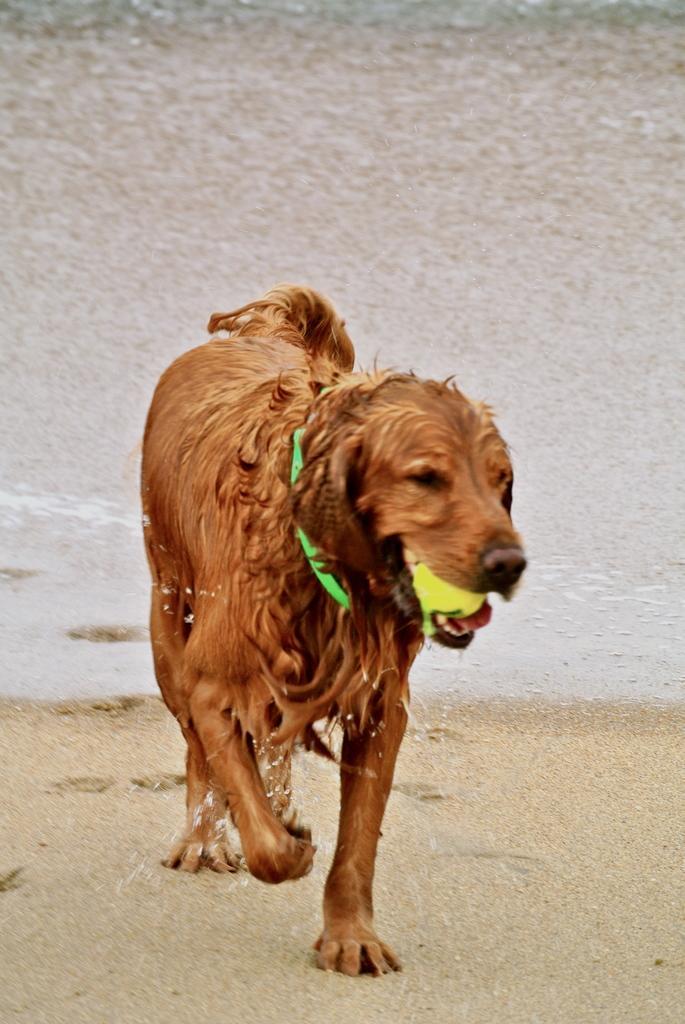Describe this image in one or two sentences. In this picture we can see the water. We can see a brown dog, a green belt around its neck. We can see a ball in the dog's mouth. At the bottom portion of the picture we can see the marks of paws on the sand. 